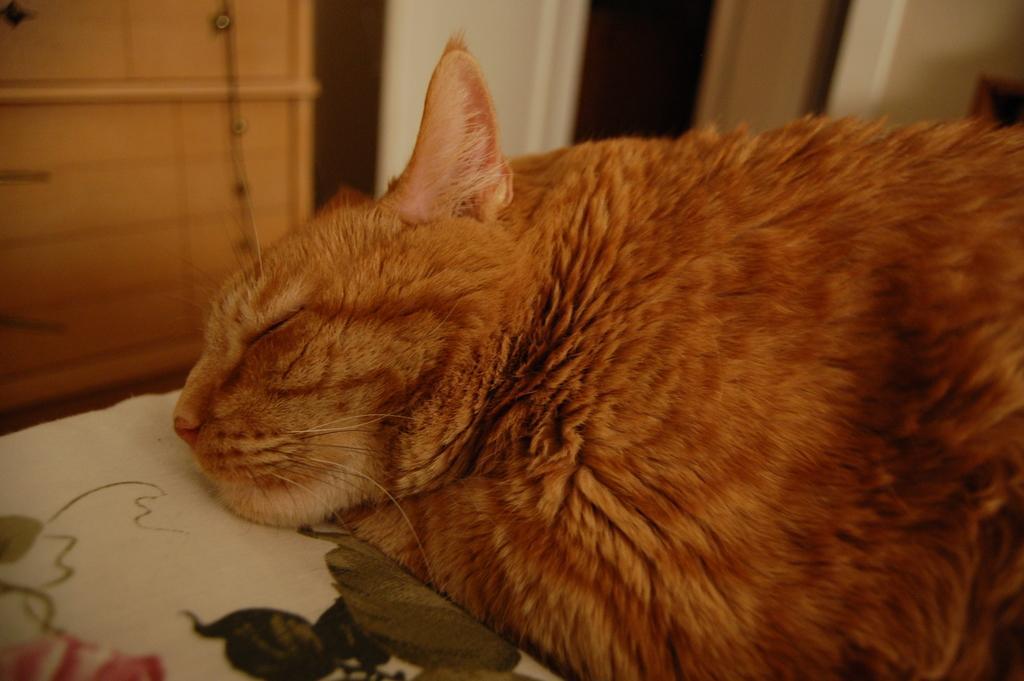Describe this image in one or two sentences. In the image we can see there is a cat lying on the bed and behind there is a wooden table. Background of the image is little blurred. 